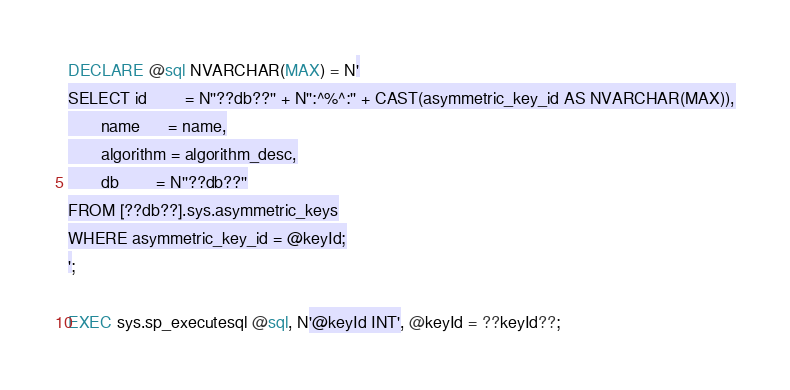Convert code to text. <code><loc_0><loc_0><loc_500><loc_500><_SQL_>DECLARE @sql NVARCHAR(MAX) = N'
SELECT id        = N''??db??'' + N'':^%^:'' + CAST(asymmetric_key_id AS NVARCHAR(MAX)),
       name      = name,
       algorithm = algorithm_desc,
       db        = N''??db??''
FROM [??db??].sys.asymmetric_keys
WHERE asymmetric_key_id = @keyId;
';

EXEC sys.sp_executesql @sql, N'@keyId INT', @keyId = ??keyId??;</code> 